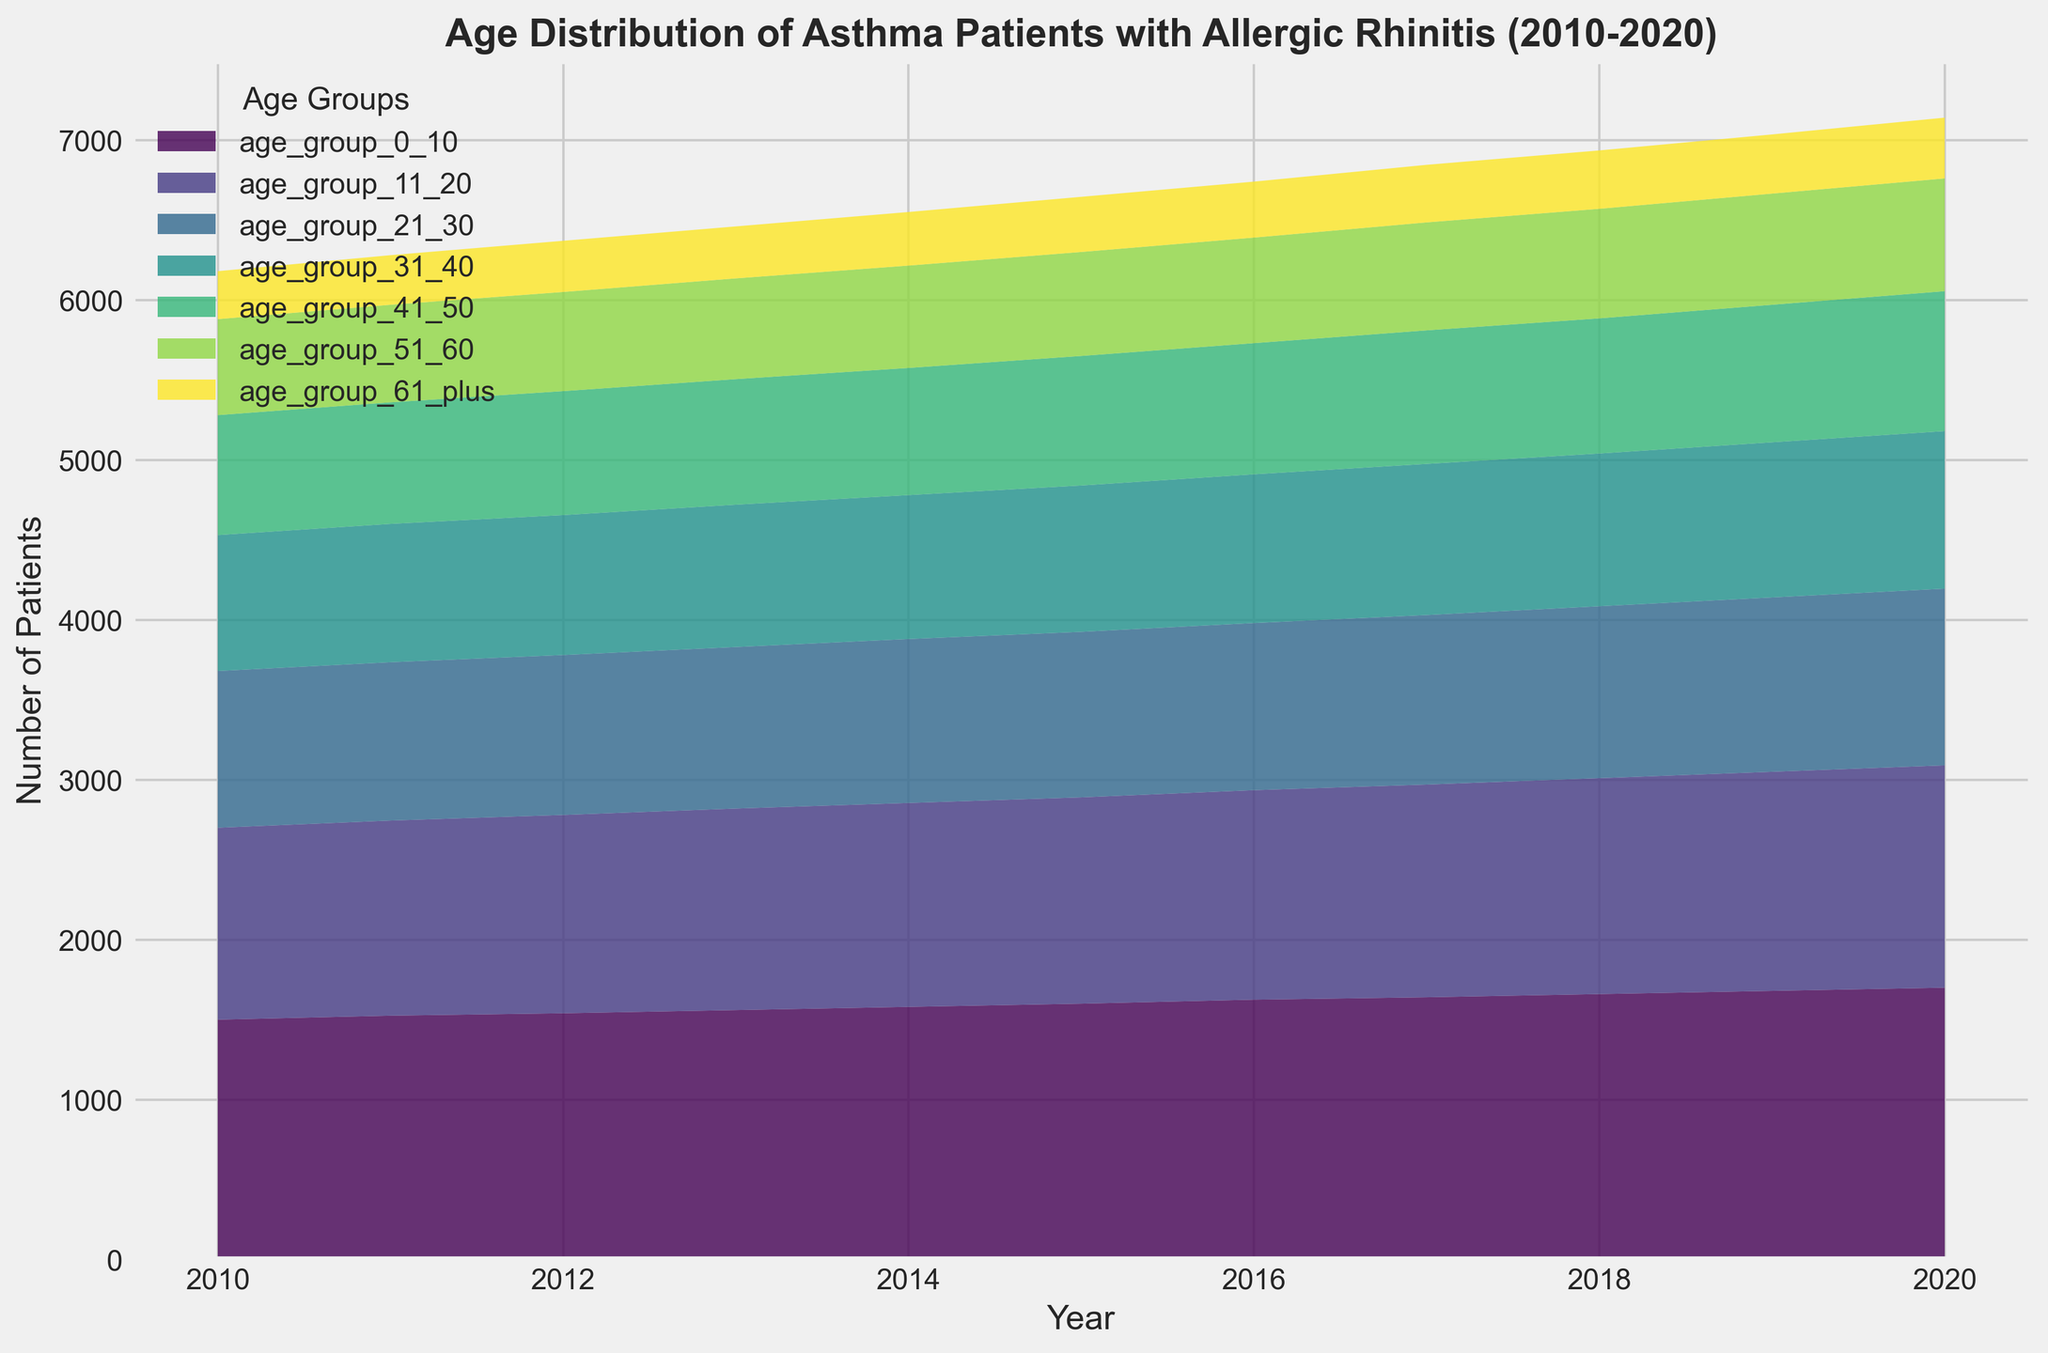what is the total number of patients in 2020? To find the total number of patients in 2020, sum up the values from all age groups for that year: 1700 (0-10) + 1390 (11-20) + 1105 (21-30) + 985 (31-40) + 875 (41-50) + 705 (51-60) + 380 (61+) = 7140
Answer: 7140 Between which years did the number of patients in the age group 21-30 increase the most? Compare the differences year-over-year for the 21-30 age group by calculating the difference for each pair of consecutive years. The largest increase happens between 2019 and 2020 since 1105 - 1090 = 15, which is greater than any other year-over-year increase for this age group
Answer: 2019 to 2020 Which age group has the steepest rise in the number of patients between 2010 and 2020? Calculate the difference in the number of patients for each age group between these years. The age group 0-10 has the steepest rise: 1700 (2020) - 1500 (2010) = 200, which is the highest among all groups
Answer: 0-10 In which year did the age group 31-40 surpass 900 patients? Review the plot and find the year where the curve representing the age group 31-40 broke the 900 mark. It happens in 2017 when the number of patients reaches 930
Answer: 2017 How many more patients were there in the 0-10 age group compared to the 61+ age group in 2015? Subtract the number of patients in the 61+ age group from the number of patients in the 0-10 age group in 2015: 1600 (0-10) - 345 (61+) = 1255
Answer: 1255 What is the average number of patients in the 11-20 age group from 2010-2020? Add all the annual numbers of patients for the 11-20 age group and divide by the total number of years: (1200+1220+1240+1260+1275+1290+1310+1330+1350+1370+1390)/11 = 1286.36
Answer: 1286.36 How does the patient count in the age group 51-60 in 2012 compare to 2020? Identify the values for 51-60 in both years: 620 (2012) and 705 (2020). Then calculate the difference: 705 - 620 = 85. So, there are 85 more patients in 2020
Answer: 85 more Which age group had the smallest increase in patient numbers from 2010 to 2020? Calculate the increase for each age group by subtracting the 2010 values from the 2020 values. The smallest increase is seen in the 61+ age group: 380 - 300 = 80
Answer: 61+ 